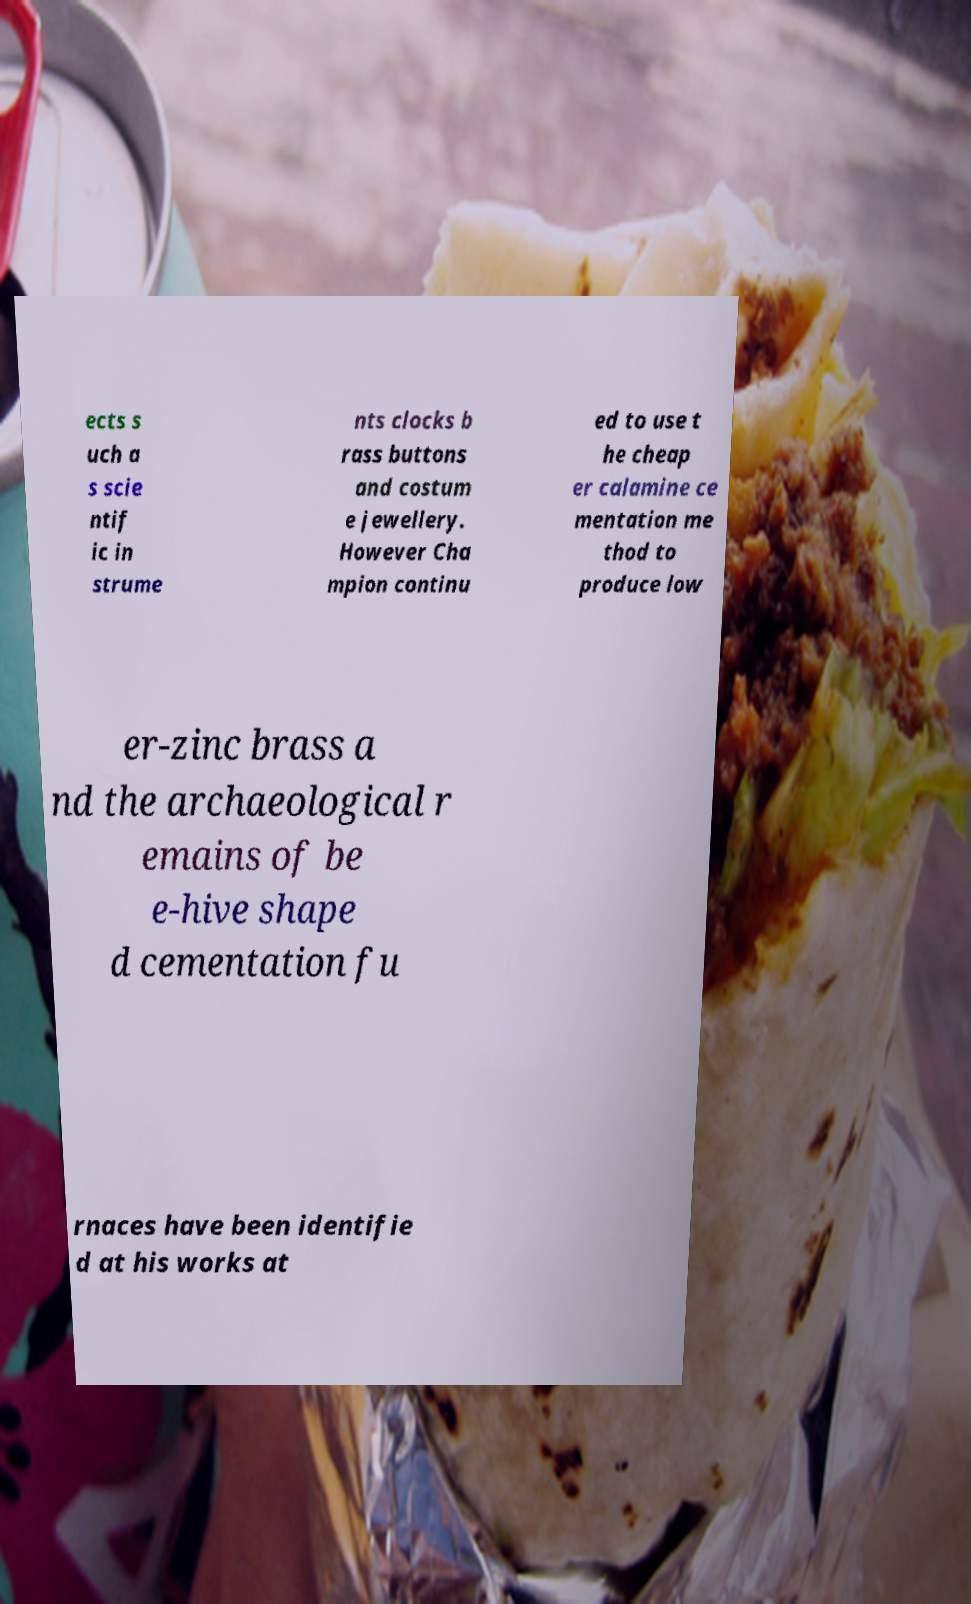There's text embedded in this image that I need extracted. Can you transcribe it verbatim? ects s uch a s scie ntif ic in strume nts clocks b rass buttons and costum e jewellery. However Cha mpion continu ed to use t he cheap er calamine ce mentation me thod to produce low er-zinc brass a nd the archaeological r emains of be e-hive shape d cementation fu rnaces have been identifie d at his works at 